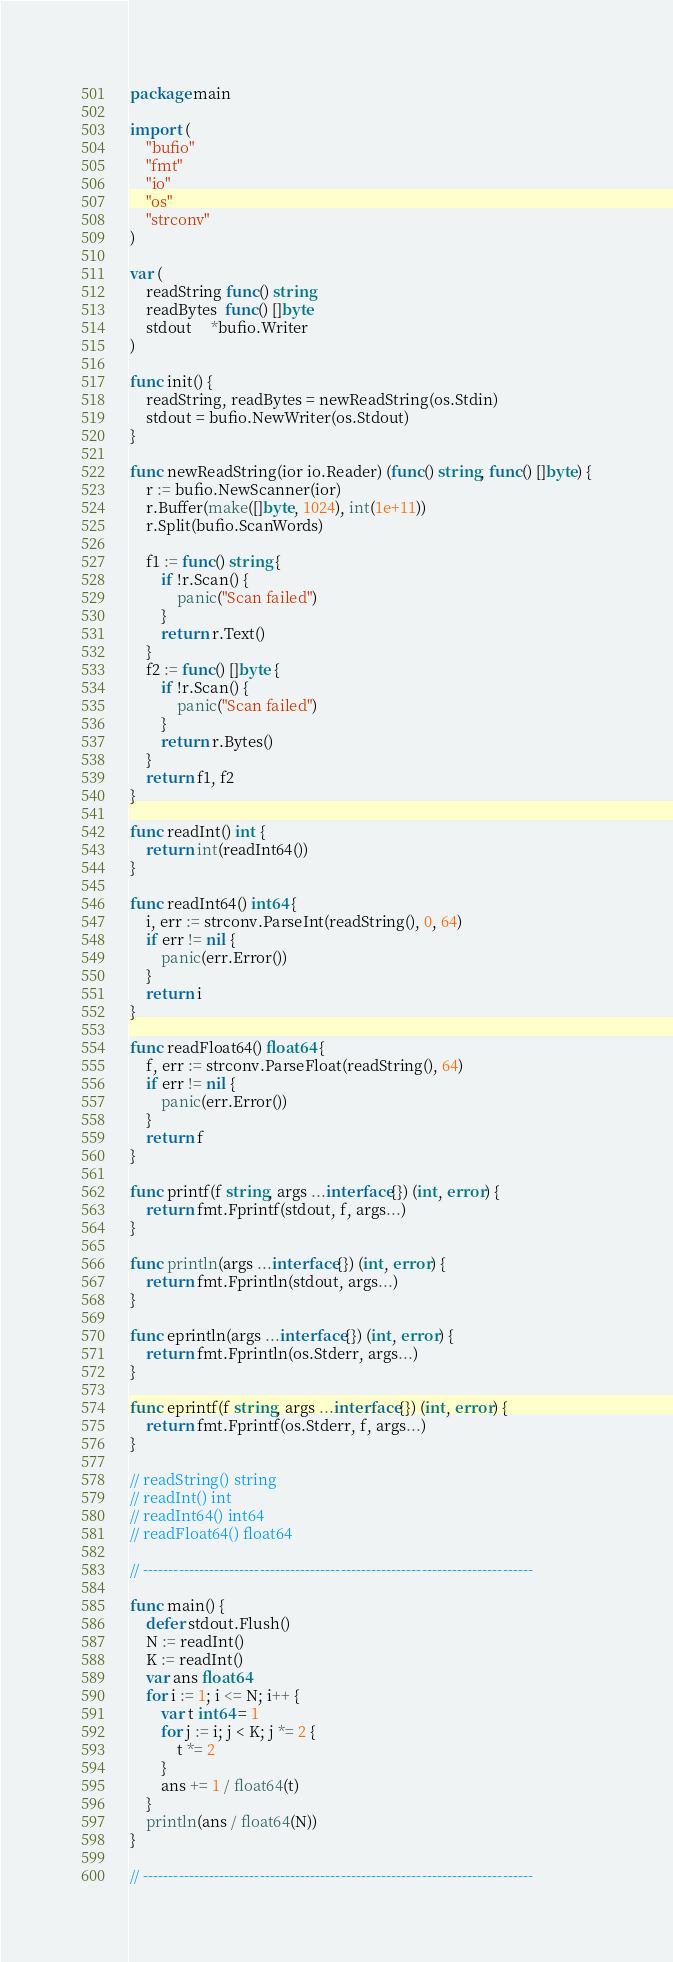Convert code to text. <code><loc_0><loc_0><loc_500><loc_500><_Go_>package main

import (
	"bufio"
	"fmt"
	"io"
	"os"
	"strconv"
)

var (
	readString func() string
	readBytes  func() []byte
	stdout     *bufio.Writer
)

func init() {
	readString, readBytes = newReadString(os.Stdin)
	stdout = bufio.NewWriter(os.Stdout)
}

func newReadString(ior io.Reader) (func() string, func() []byte) {
	r := bufio.NewScanner(ior)
	r.Buffer(make([]byte, 1024), int(1e+11))
	r.Split(bufio.ScanWords)

	f1 := func() string {
		if !r.Scan() {
			panic("Scan failed")
		}
		return r.Text()
	}
	f2 := func() []byte {
		if !r.Scan() {
			panic("Scan failed")
		}
		return r.Bytes()
	}
	return f1, f2
}

func readInt() int {
	return int(readInt64())
}

func readInt64() int64 {
	i, err := strconv.ParseInt(readString(), 0, 64)
	if err != nil {
		panic(err.Error())
	}
	return i
}

func readFloat64() float64 {
	f, err := strconv.ParseFloat(readString(), 64)
	if err != nil {
		panic(err.Error())
	}
	return f
}

func printf(f string, args ...interface{}) (int, error) {
	return fmt.Fprintf(stdout, f, args...)
}

func println(args ...interface{}) (int, error) {
	return fmt.Fprintln(stdout, args...)
}

func eprintln(args ...interface{}) (int, error) {
	return fmt.Fprintln(os.Stderr, args...)
}

func eprintf(f string, args ...interface{}) (int, error) {
	return fmt.Fprintf(os.Stderr, f, args...)
}

// readString() string
// readInt() int
// readInt64() int64
// readFloat64() float64

// -----------------------------------------------------------------------------

func main() {
	defer stdout.Flush()
	N := readInt()
	K := readInt()
	var ans float64
	for i := 1; i <= N; i++ {
		var t int64 = 1
		for j := i; j < K; j *= 2 {
			t *= 2
		}
		ans += 1 / float64(t)
	}
	println(ans / float64(N))
}

// -----------------------------------------------------------------------------
</code> 